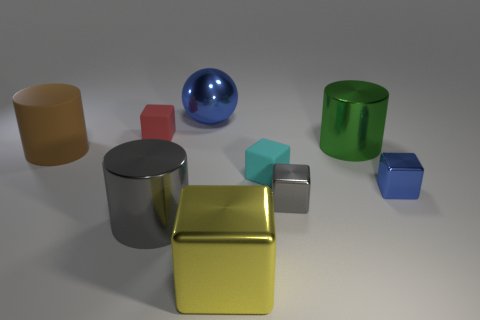Can you describe the objects and their arrangement in the image? Certainly! In the image, you see a collection of geometric solids. There's a large blue sphere to the left, centered behind a shiny gold cube. To the left of the gold cube is a reflective gray cylinder, and a matte beige cylinder is seen farther left. In front, there are smaller cubes in red, teal, and two shades of blue, along with a green hollow cylinder. These objects are arranged on a flat, gray surface with a light source casting soft shadows, creating a sense of depth. 